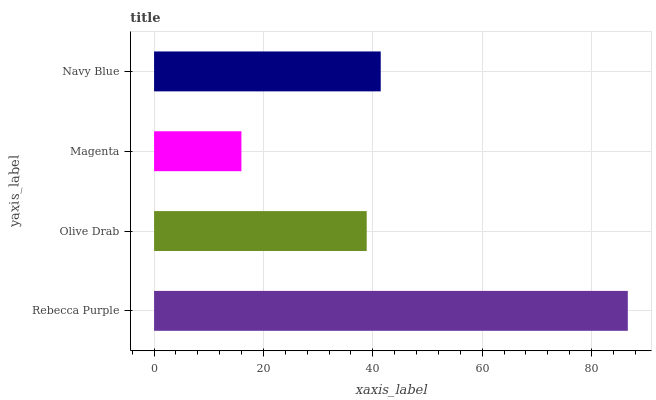Is Magenta the minimum?
Answer yes or no. Yes. Is Rebecca Purple the maximum?
Answer yes or no. Yes. Is Olive Drab the minimum?
Answer yes or no. No. Is Olive Drab the maximum?
Answer yes or no. No. Is Rebecca Purple greater than Olive Drab?
Answer yes or no. Yes. Is Olive Drab less than Rebecca Purple?
Answer yes or no. Yes. Is Olive Drab greater than Rebecca Purple?
Answer yes or no. No. Is Rebecca Purple less than Olive Drab?
Answer yes or no. No. Is Navy Blue the high median?
Answer yes or no. Yes. Is Olive Drab the low median?
Answer yes or no. Yes. Is Magenta the high median?
Answer yes or no. No. Is Navy Blue the low median?
Answer yes or no. No. 